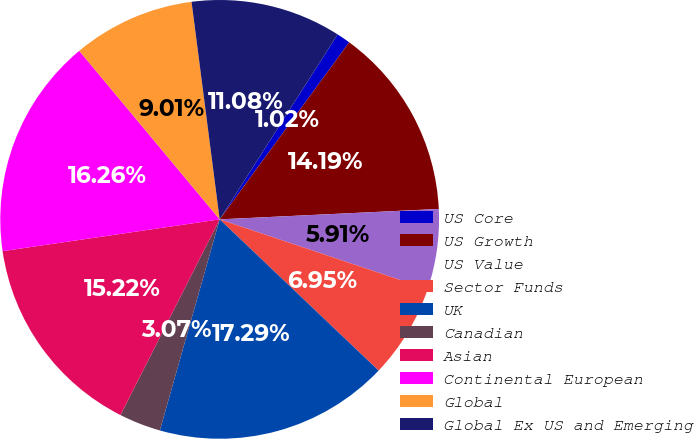Convert chart. <chart><loc_0><loc_0><loc_500><loc_500><pie_chart><fcel>US Core<fcel>US Growth<fcel>US Value<fcel>Sector Funds<fcel>UK<fcel>Canadian<fcel>Asian<fcel>Continental European<fcel>Global<fcel>Global Ex US and Emerging<nl><fcel>1.02%<fcel>14.19%<fcel>5.91%<fcel>6.95%<fcel>17.29%<fcel>3.07%<fcel>15.22%<fcel>16.26%<fcel>9.01%<fcel>11.08%<nl></chart> 